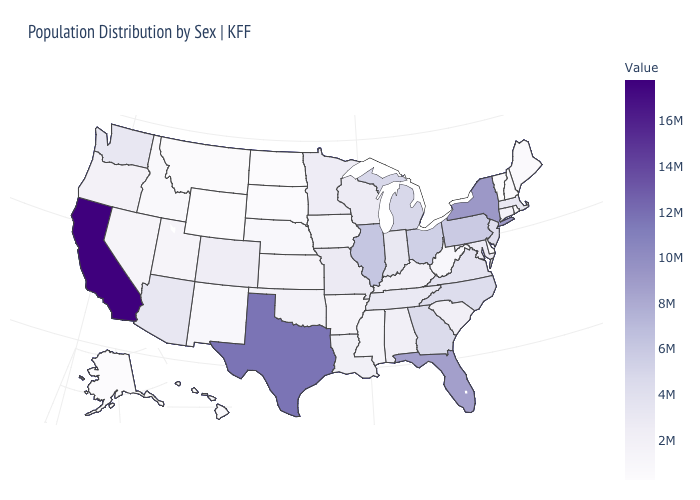Which states have the lowest value in the USA?
Short answer required. Wyoming. Does Mississippi have the highest value in the USA?
Be succinct. No. Does the map have missing data?
Short answer required. No. Among the states that border Idaho , which have the highest value?
Be succinct. Washington. Which states have the lowest value in the USA?
Be succinct. Wyoming. Among the states that border Virginia , which have the lowest value?
Be succinct. West Virginia. 